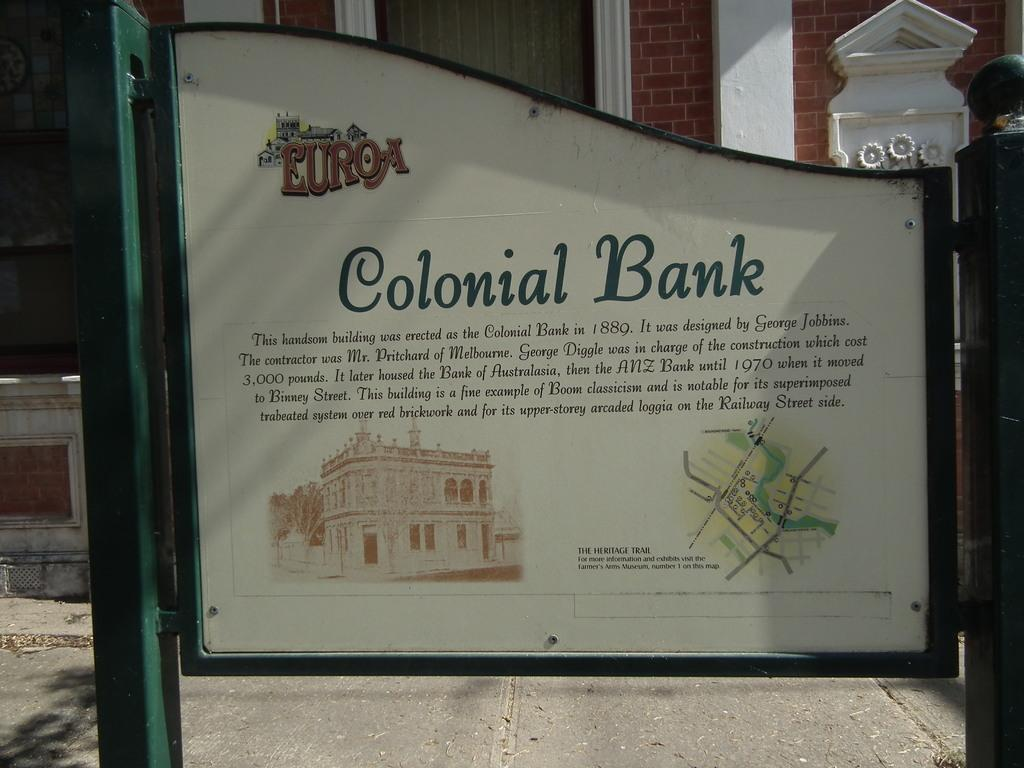<image>
Offer a succinct explanation of the picture presented. A sign gives information about a colonial bank. 